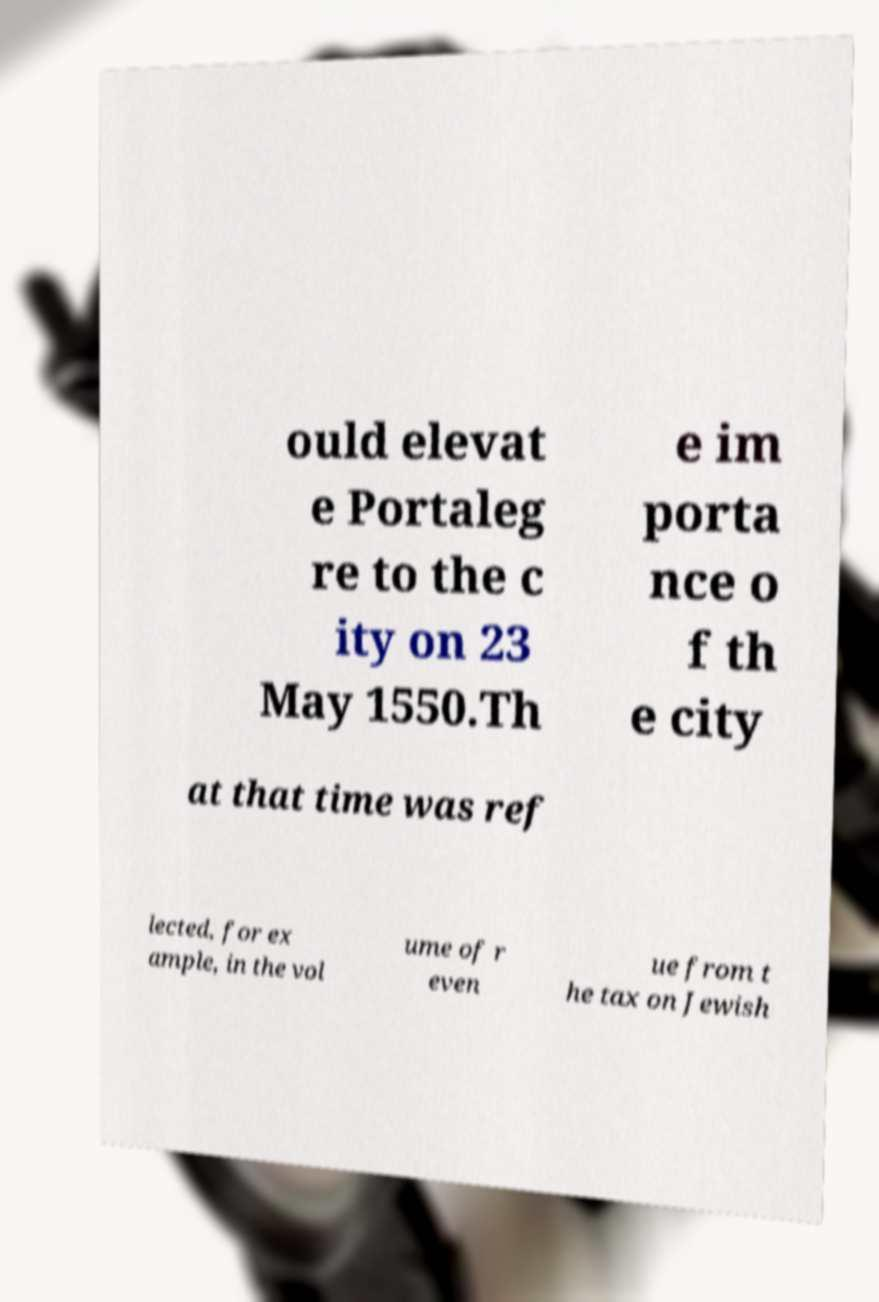Could you assist in decoding the text presented in this image and type it out clearly? ould elevat e Portaleg re to the c ity on 23 May 1550.Th e im porta nce o f th e city at that time was ref lected, for ex ample, in the vol ume of r even ue from t he tax on Jewish 